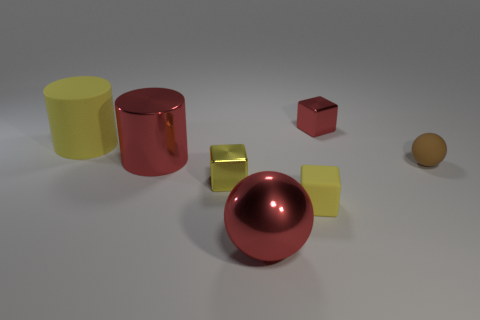Subtract all small rubber cubes. How many cubes are left? 2 Subtract all gray cylinders. How many yellow blocks are left? 2 Add 2 tiny red metallic cubes. How many objects exist? 9 Subtract all red cubes. How many cubes are left? 2 Subtract all cylinders. How many objects are left? 5 Subtract 1 balls. How many balls are left? 1 Add 4 big yellow things. How many big yellow things are left? 5 Add 4 big cylinders. How many big cylinders exist? 6 Subtract 0 gray balls. How many objects are left? 7 Subtract all red spheres. Subtract all cyan blocks. How many spheres are left? 1 